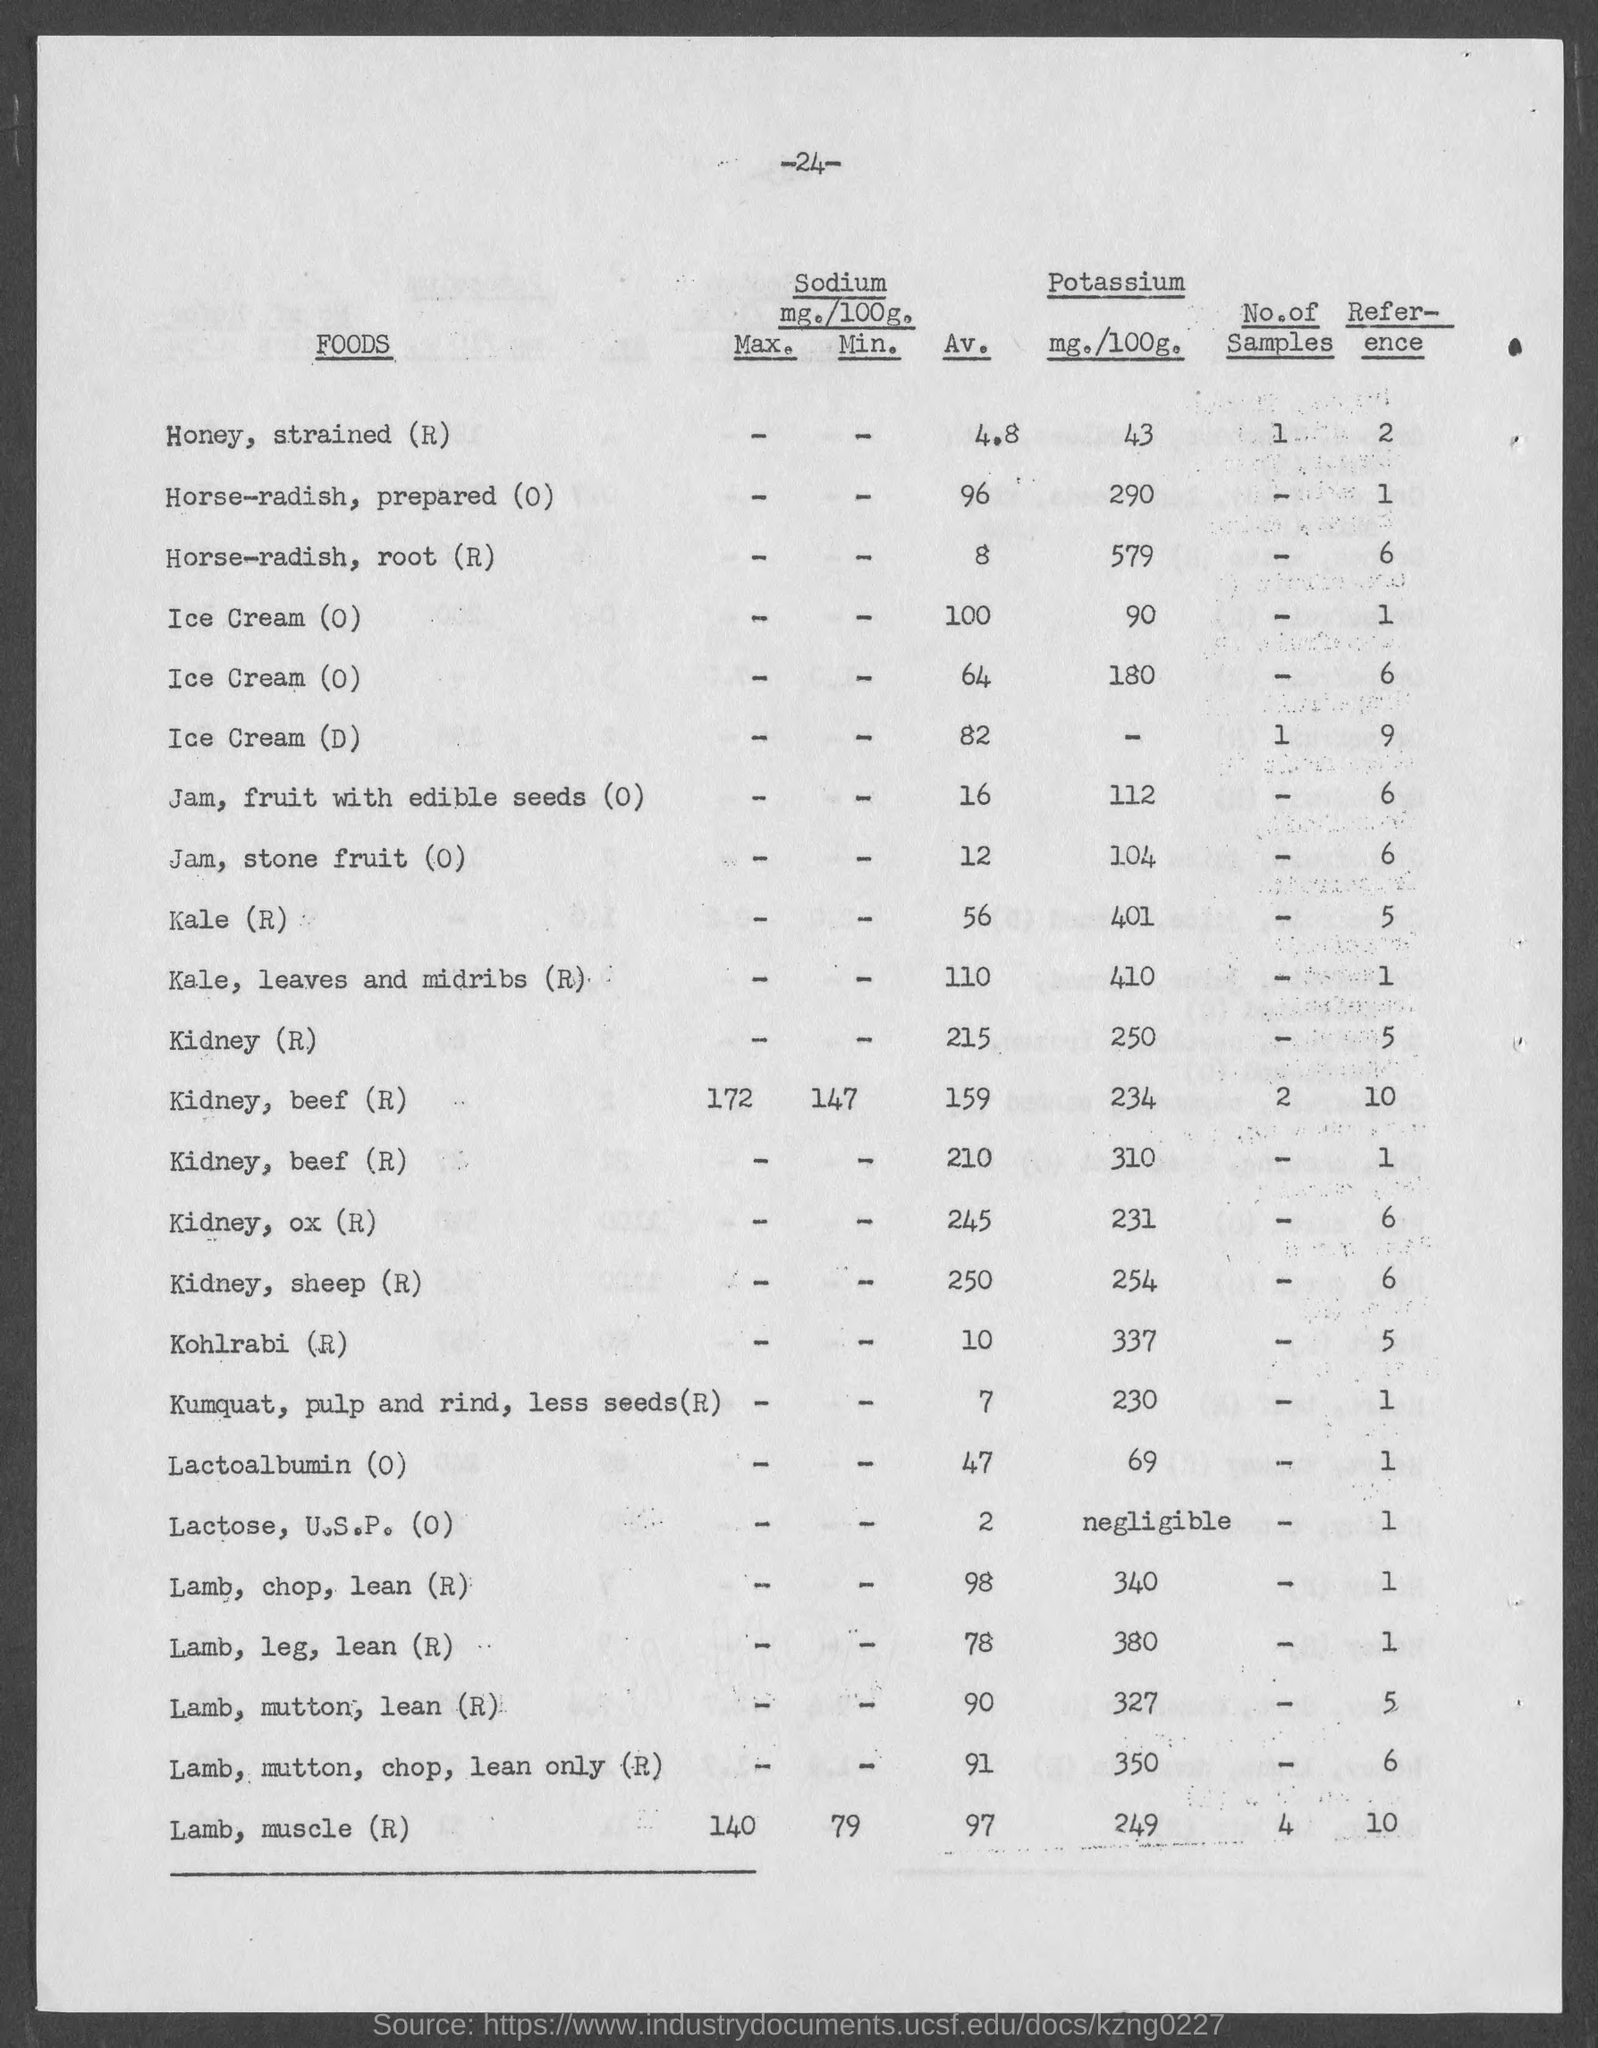Indicate a few pertinent items in this graphic. Kohlrabi (R) contains approximately 337 mg of potassium per 100 grams. A serving of Kale (R) contains approximately 401 milligrams of potassium per 100 grams. There is 43 grams of honey containing 100 milligrams of potassium per 100 grams. There is a very small amount of potassium present in Lactose, U.S.P. (0), which is almost negligible. 